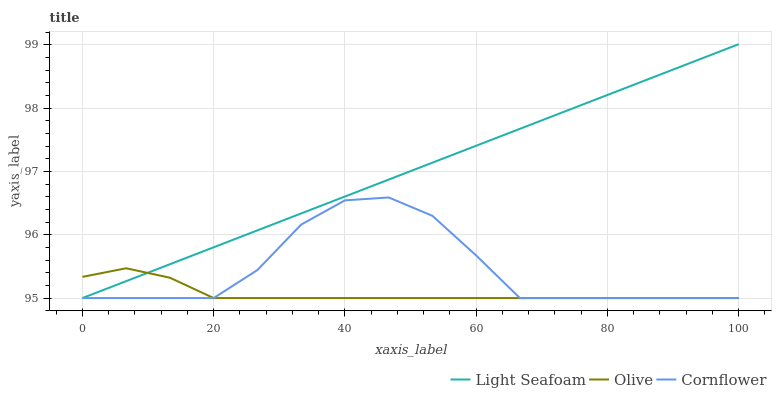Does Olive have the minimum area under the curve?
Answer yes or no. Yes. Does Light Seafoam have the maximum area under the curve?
Answer yes or no. Yes. Does Cornflower have the minimum area under the curve?
Answer yes or no. No. Does Cornflower have the maximum area under the curve?
Answer yes or no. No. Is Light Seafoam the smoothest?
Answer yes or no. Yes. Is Cornflower the roughest?
Answer yes or no. Yes. Is Cornflower the smoothest?
Answer yes or no. No. Is Light Seafoam the roughest?
Answer yes or no. No. Does Olive have the lowest value?
Answer yes or no. Yes. Does Light Seafoam have the highest value?
Answer yes or no. Yes. Does Cornflower have the highest value?
Answer yes or no. No. Does Cornflower intersect Light Seafoam?
Answer yes or no. Yes. Is Cornflower less than Light Seafoam?
Answer yes or no. No. Is Cornflower greater than Light Seafoam?
Answer yes or no. No. 